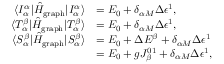Convert formula to latex. <formula><loc_0><loc_0><loc_500><loc_500>\begin{array} { r l } { \langle I _ { \alpha } ^ { \alpha } | \hat { H } _ { g r a p h } | I _ { \alpha } ^ { \alpha } \rangle } & { = E _ { 0 } + \delta _ { \alpha M } \Delta \epsilon ^ { 1 } , } \\ { \langle T _ { \alpha } ^ { \beta } | \hat { H } _ { g r a p h } | T _ { \alpha } ^ { \beta } \rangle } & { = E _ { 0 } + \delta _ { \alpha M } \Delta \epsilon ^ { 1 } , } \\ { \langle S _ { \alpha } ^ { \beta } | \hat { H } _ { g r a p h } | S _ { \alpha } ^ { \beta } \rangle } & { = E _ { 0 } + \Delta E ^ { \beta } + \delta _ { \alpha M } \Delta \epsilon ^ { 1 } } \\ & { = E _ { 0 } + g J _ { \beta } ^ { 0 1 } + \delta _ { \alpha M } \Delta \epsilon ^ { 1 } , } \end{array}</formula> 